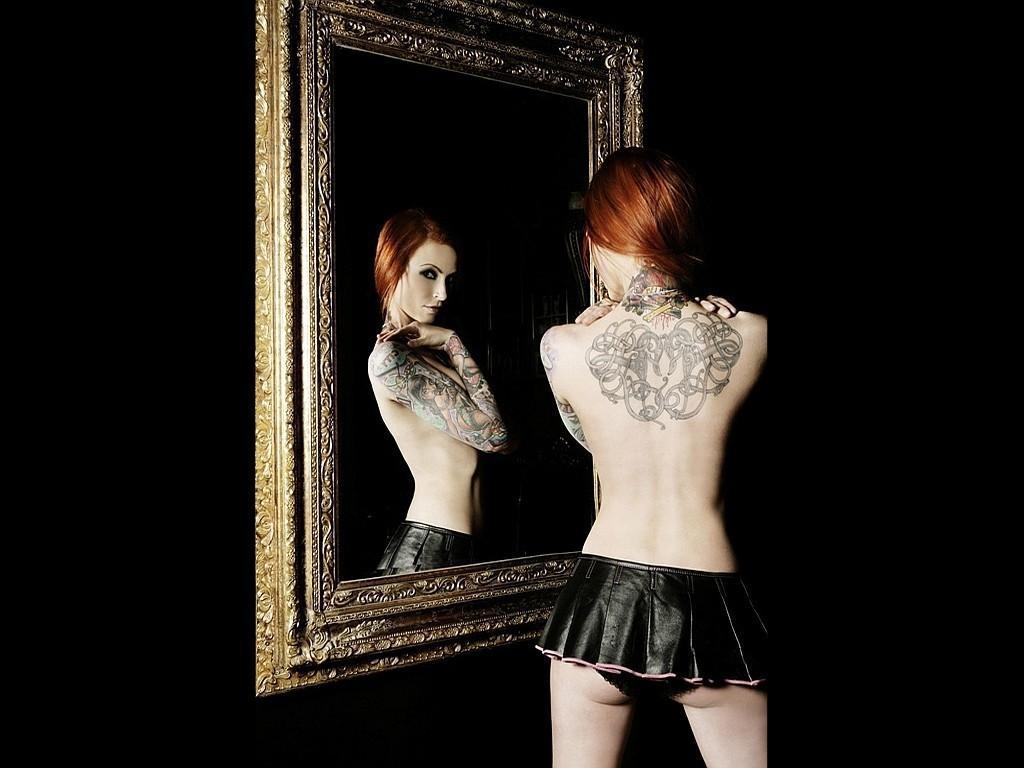Could you give a brief overview of what you see in this image? In this image there is a woman standing in front of the mirror, background is dark. 